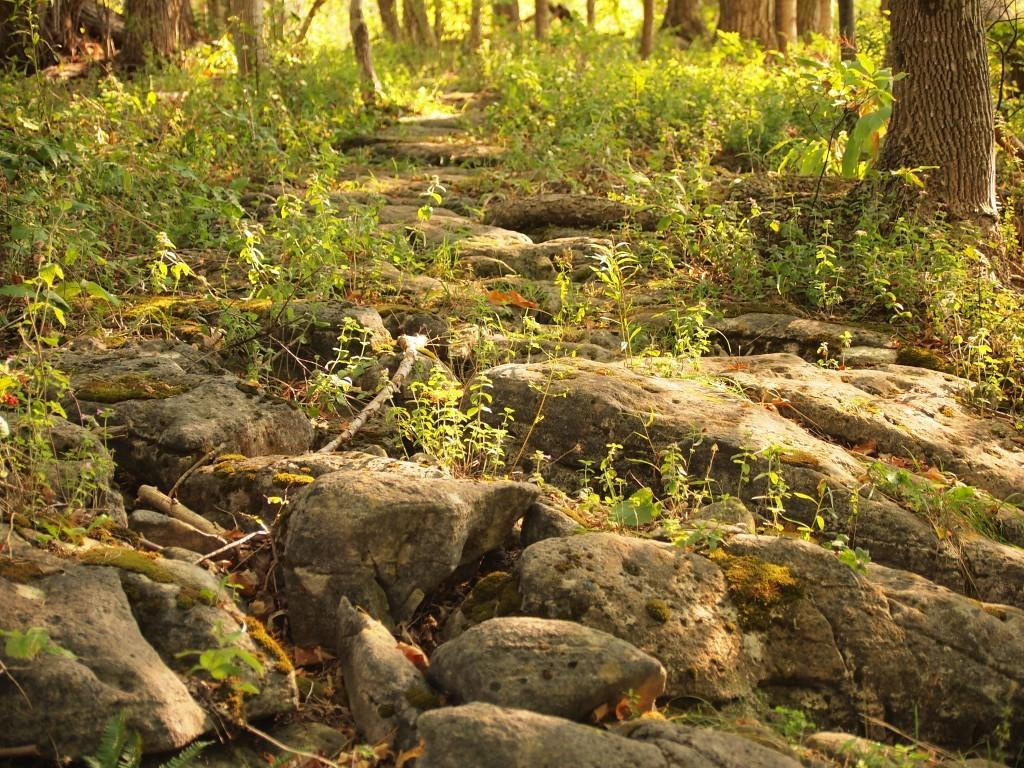What type of natural elements can be seen in the image? There are stones, grass, and trees in the image. Can you describe the ground in the image? The ground in the image is covered with grass. What else can be found in the image besides the grass? There are stones and trees in the image. What type of amusement can be seen in the image? There is no amusement present in the image; it features natural elements such as stones, grass, and trees. How does the daughter interact with the stones in the image? There is no daughter present in the image, so it is not possible to answer how she might interact with the stones. 